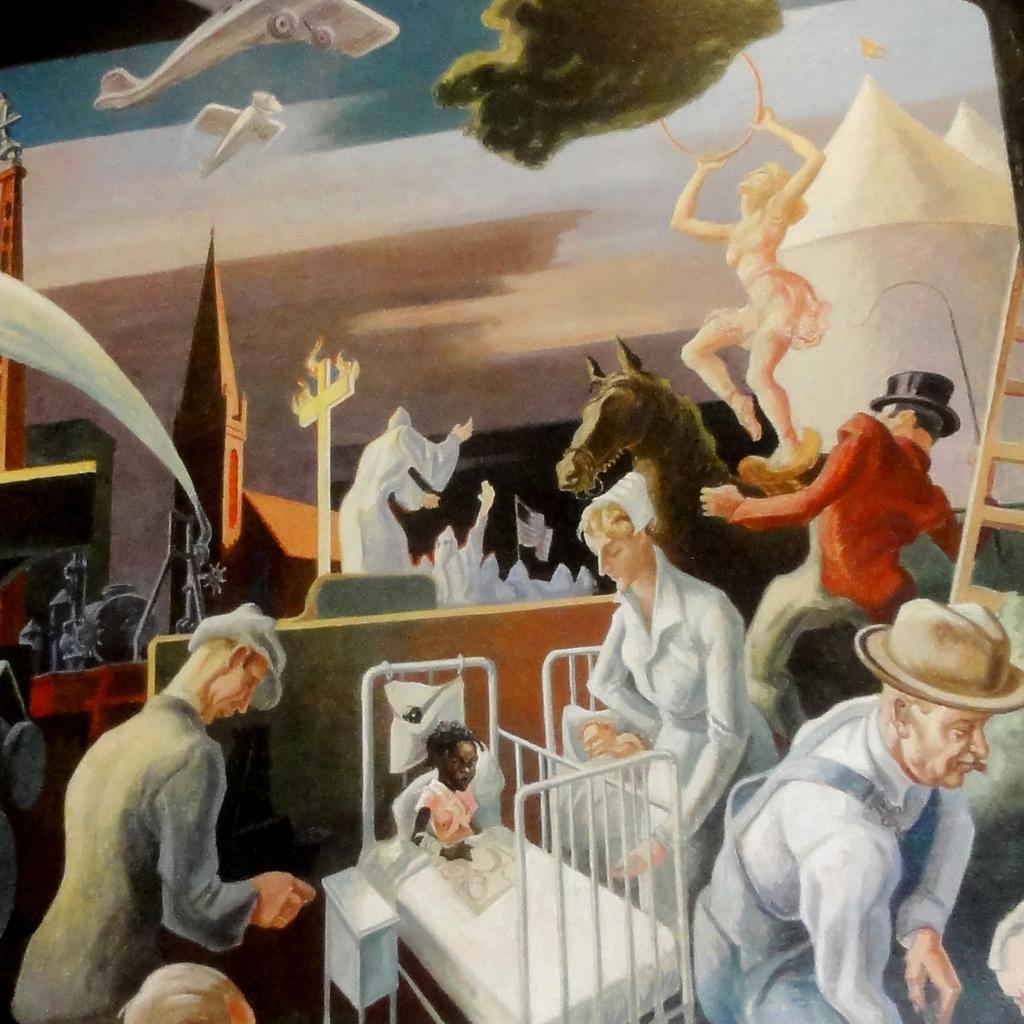Can you describe this image briefly? This picture is painting. We can see some of persons are present and also we can see bed, table, ladder are there. At the top of the image an aeroplane, sky, building are present. 